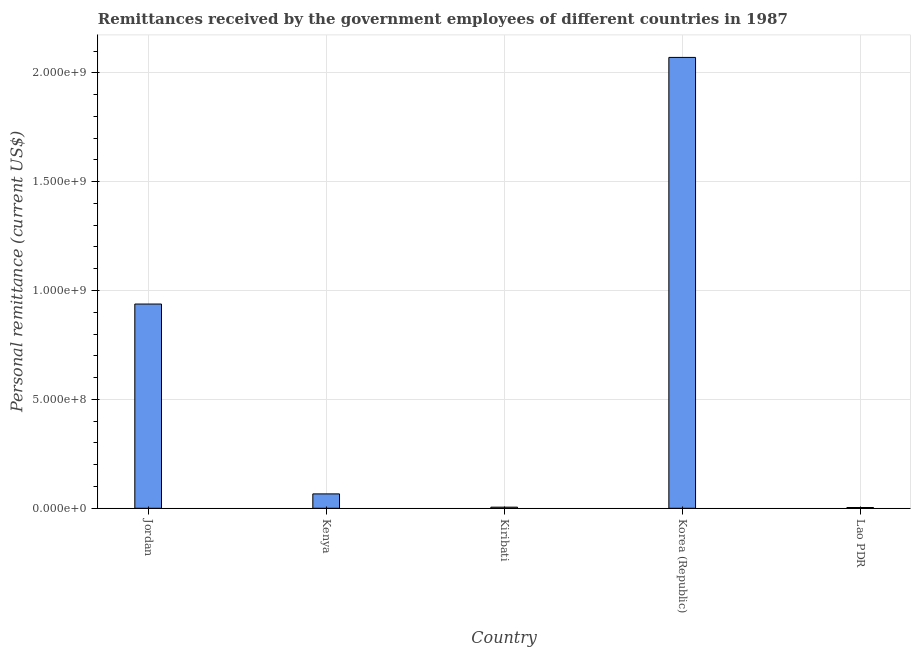What is the title of the graph?
Keep it short and to the point. Remittances received by the government employees of different countries in 1987. What is the label or title of the Y-axis?
Keep it short and to the point. Personal remittance (current US$). What is the personal remittances in Jordan?
Your answer should be very brief. 9.38e+08. Across all countries, what is the maximum personal remittances?
Your response must be concise. 2.07e+09. Across all countries, what is the minimum personal remittances?
Keep it short and to the point. 3.50e+06. In which country was the personal remittances minimum?
Your answer should be compact. Lao PDR. What is the sum of the personal remittances?
Make the answer very short. 3.08e+09. What is the difference between the personal remittances in Kenya and Lao PDR?
Keep it short and to the point. 6.25e+07. What is the average personal remittances per country?
Give a very brief answer. 6.17e+08. What is the median personal remittances?
Your response must be concise. 6.60e+07. In how many countries, is the personal remittances greater than 1700000000 US$?
Keep it short and to the point. 1. What is the ratio of the personal remittances in Kenya to that in Lao PDR?
Offer a terse response. 18.86. What is the difference between the highest and the second highest personal remittances?
Offer a terse response. 1.13e+09. Is the sum of the personal remittances in Jordan and Kenya greater than the maximum personal remittances across all countries?
Your response must be concise. No. What is the difference between the highest and the lowest personal remittances?
Keep it short and to the point. 2.07e+09. Are all the bars in the graph horizontal?
Offer a very short reply. No. What is the Personal remittance (current US$) of Jordan?
Provide a short and direct response. 9.38e+08. What is the Personal remittance (current US$) in Kenya?
Offer a terse response. 6.60e+07. What is the Personal remittance (current US$) in Kiribati?
Give a very brief answer. 5.10e+06. What is the Personal remittance (current US$) of Korea (Republic)?
Your answer should be very brief. 2.07e+09. What is the Personal remittance (current US$) of Lao PDR?
Your answer should be compact. 3.50e+06. What is the difference between the Personal remittance (current US$) in Jordan and Kenya?
Keep it short and to the point. 8.72e+08. What is the difference between the Personal remittance (current US$) in Jordan and Kiribati?
Your answer should be very brief. 9.33e+08. What is the difference between the Personal remittance (current US$) in Jordan and Korea (Republic)?
Make the answer very short. -1.13e+09. What is the difference between the Personal remittance (current US$) in Jordan and Lao PDR?
Ensure brevity in your answer.  9.34e+08. What is the difference between the Personal remittance (current US$) in Kenya and Kiribati?
Offer a very short reply. 6.09e+07. What is the difference between the Personal remittance (current US$) in Kenya and Korea (Republic)?
Ensure brevity in your answer.  -2.00e+09. What is the difference between the Personal remittance (current US$) in Kenya and Lao PDR?
Give a very brief answer. 6.25e+07. What is the difference between the Personal remittance (current US$) in Kiribati and Korea (Republic)?
Keep it short and to the point. -2.07e+09. What is the difference between the Personal remittance (current US$) in Kiribati and Lao PDR?
Provide a short and direct response. 1.60e+06. What is the difference between the Personal remittance (current US$) in Korea (Republic) and Lao PDR?
Keep it short and to the point. 2.07e+09. What is the ratio of the Personal remittance (current US$) in Jordan to that in Kenya?
Your answer should be very brief. 14.21. What is the ratio of the Personal remittance (current US$) in Jordan to that in Kiribati?
Your response must be concise. 183.88. What is the ratio of the Personal remittance (current US$) in Jordan to that in Korea (Republic)?
Ensure brevity in your answer.  0.45. What is the ratio of the Personal remittance (current US$) in Jordan to that in Lao PDR?
Your answer should be very brief. 267.99. What is the ratio of the Personal remittance (current US$) in Kenya to that in Kiribati?
Your answer should be very brief. 12.94. What is the ratio of the Personal remittance (current US$) in Kenya to that in Korea (Republic)?
Provide a succinct answer. 0.03. What is the ratio of the Personal remittance (current US$) in Kenya to that in Lao PDR?
Offer a very short reply. 18.86. What is the ratio of the Personal remittance (current US$) in Kiribati to that in Korea (Republic)?
Ensure brevity in your answer.  0. What is the ratio of the Personal remittance (current US$) in Kiribati to that in Lao PDR?
Keep it short and to the point. 1.46. What is the ratio of the Personal remittance (current US$) in Korea (Republic) to that in Lao PDR?
Your response must be concise. 591.6. 